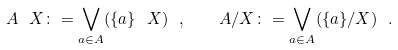Convert formula to latex. <formula><loc_0><loc_0><loc_500><loc_500>A \ X \colon = \bigvee _ { a \in A } ( \{ a \} \ X ) \ , \quad A / X \colon = \bigvee _ { a \in A } ( \{ a \} / X ) \ .</formula> 